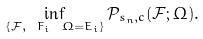Convert formula to latex. <formula><loc_0><loc_0><loc_500><loc_500>\inf _ { \{ \mathcal { F } , \ F _ { i } \ \Omega = \bar { E } _ { i } \} } \mathcal { P } _ { s _ { n } , c } ( \mathcal { F } ; \Omega ) .</formula> 